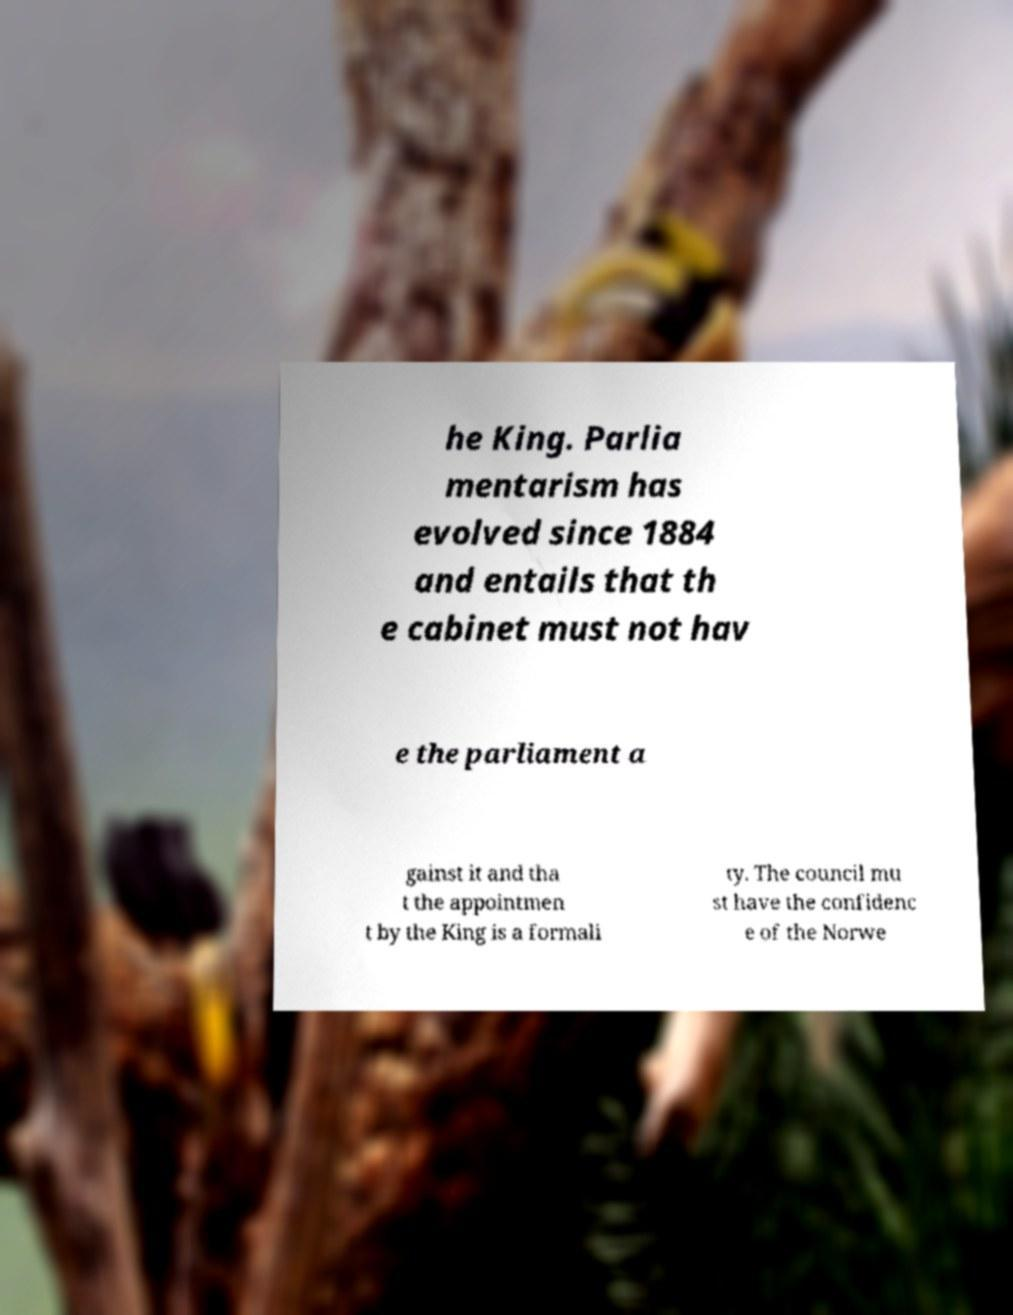For documentation purposes, I need the text within this image transcribed. Could you provide that? he King. Parlia mentarism has evolved since 1884 and entails that th e cabinet must not hav e the parliament a gainst it and tha t the appointmen t by the King is a formali ty. The council mu st have the confidenc e of the Norwe 